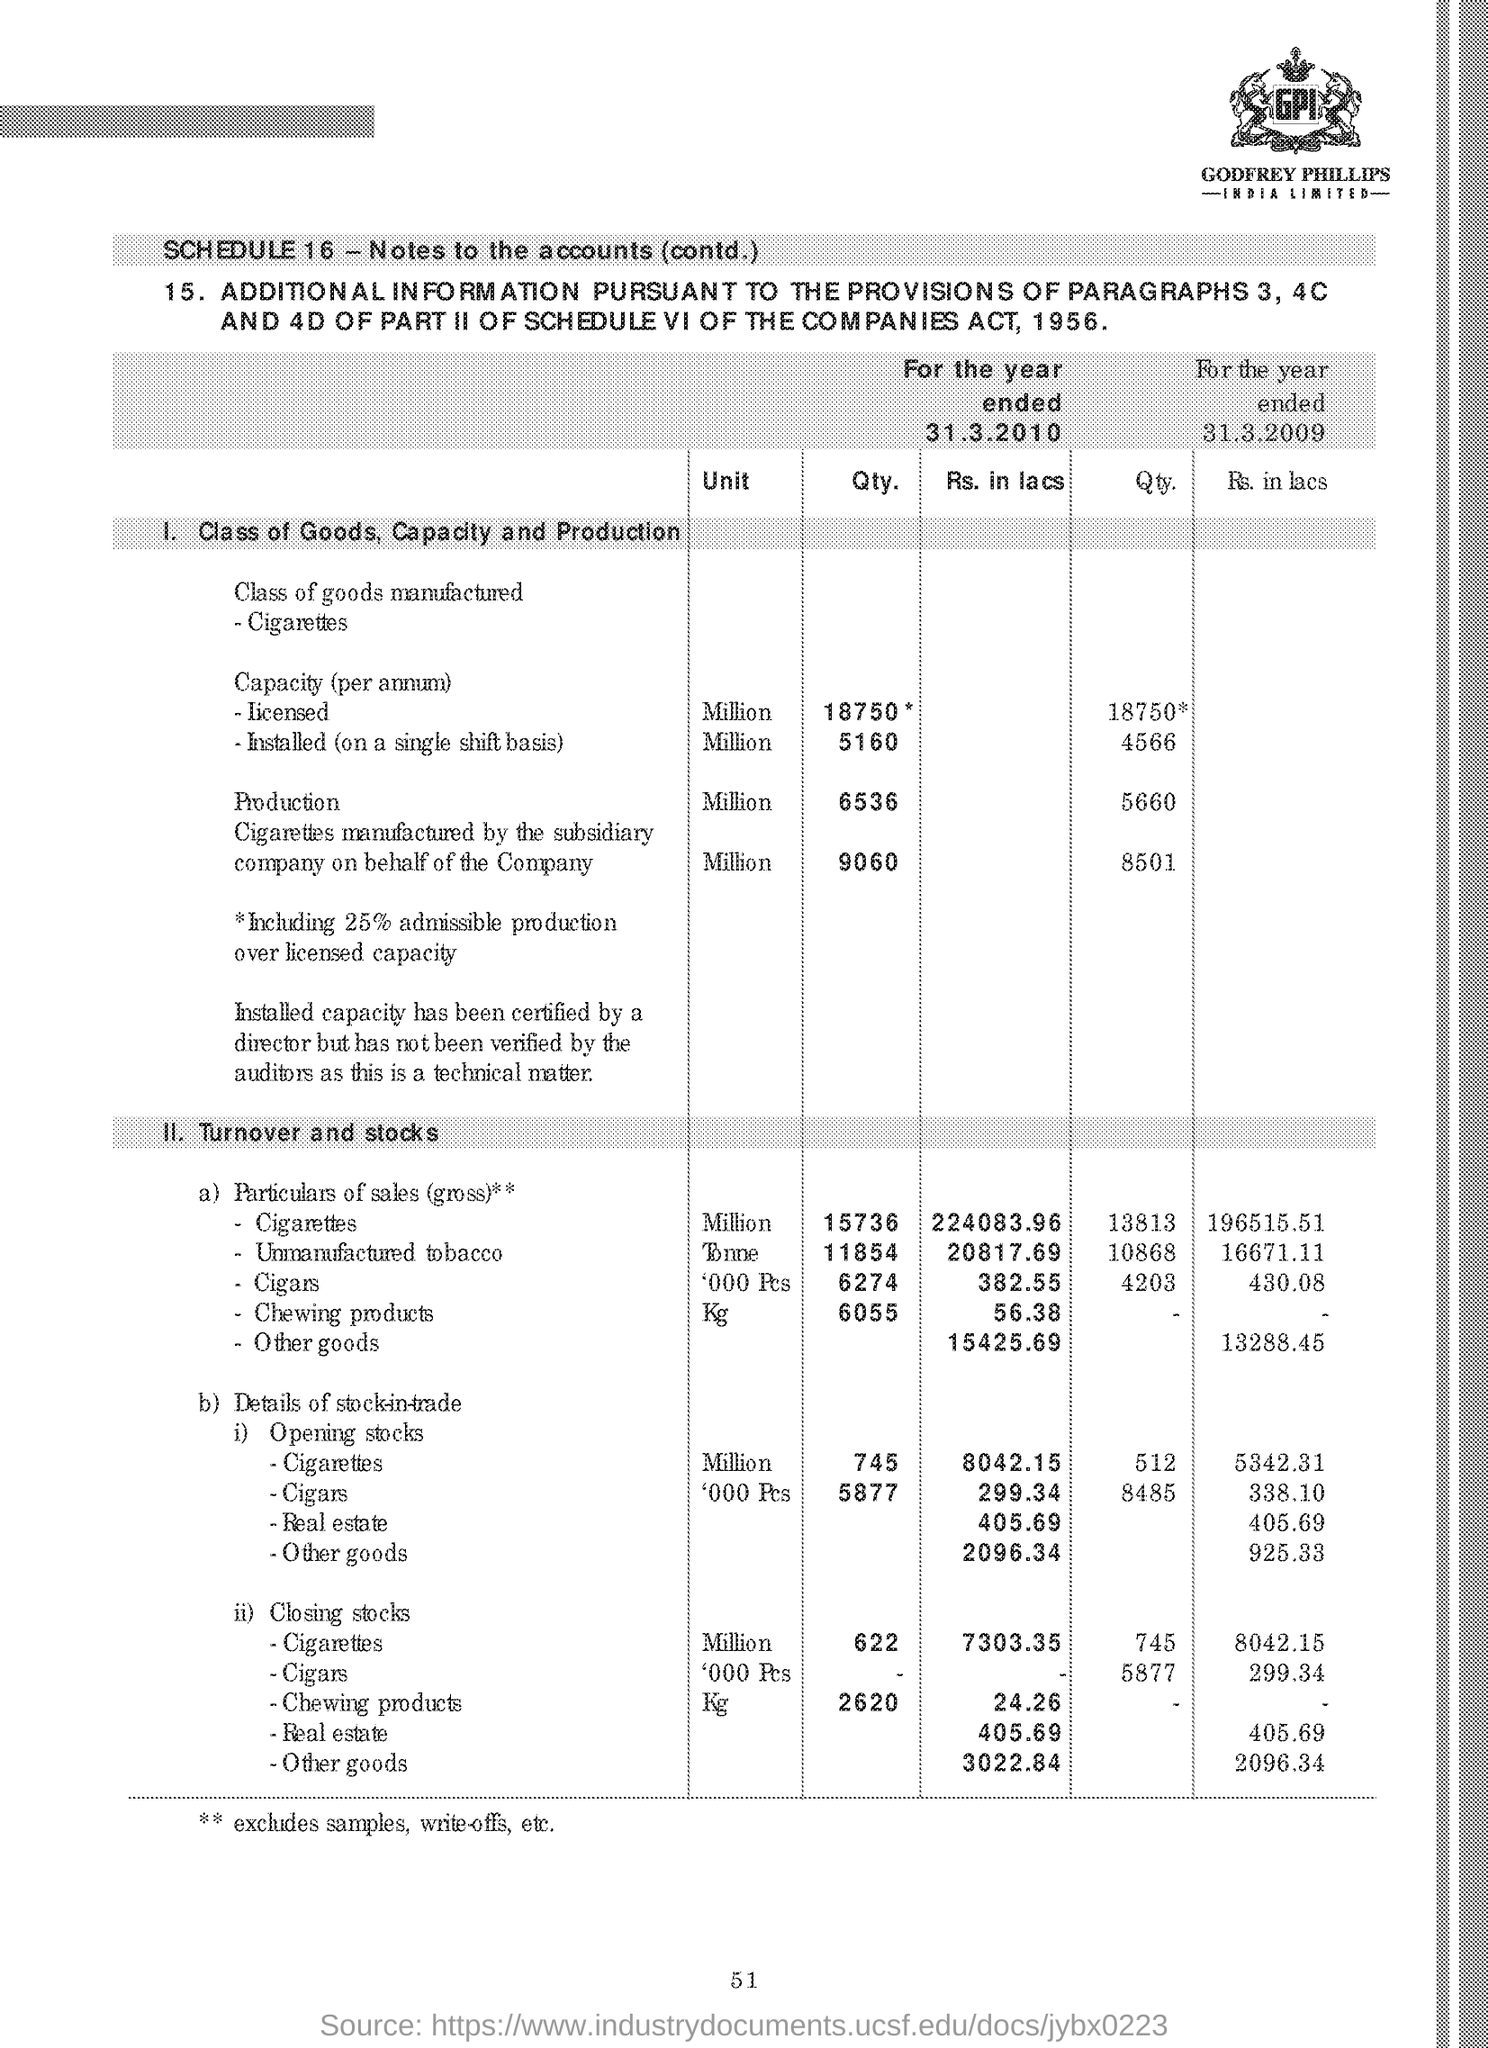How much is Qty. of  'Licensed Capacity(per annum)' for the year ended 31.3.2010?
Offer a terse response. 18750*. What is the unit specified for Qty. under the subheading '1.Class of Goods, Capacity and Production' ?
Your response must be concise. Million. What is the 'Qty.' of Closing stocks of 'Cigarettes' for the year 31.3.2010 based on subheading 'II. Turnover and stocks' ?
Provide a succinct answer. 622. What is the page number given at the footer?
Provide a succinct answer. 51. What the ** symbol denotes based of the end of the document?
Ensure brevity in your answer.  Excludes samples, write-offs, etc. 